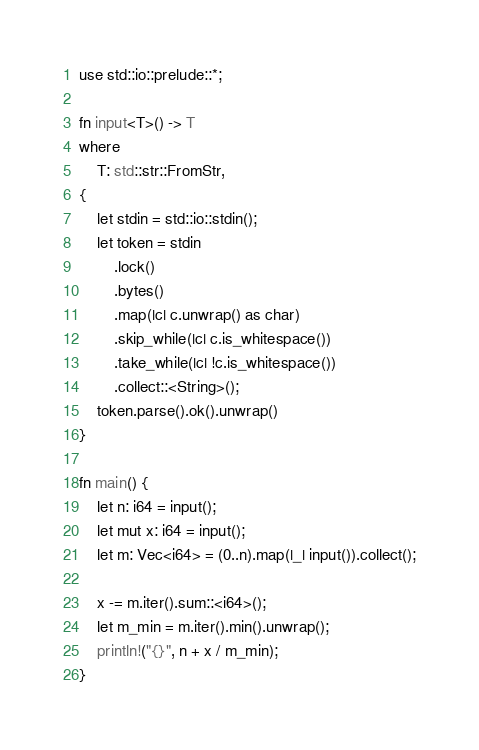Convert code to text. <code><loc_0><loc_0><loc_500><loc_500><_Rust_>use std::io::prelude::*;

fn input<T>() -> T
where
    T: std::str::FromStr,
{
    let stdin = std::io::stdin();
    let token = stdin
        .lock()
        .bytes()
        .map(|c| c.unwrap() as char)
        .skip_while(|c| c.is_whitespace())
        .take_while(|c| !c.is_whitespace())
        .collect::<String>();
    token.parse().ok().unwrap()
}

fn main() {
    let n: i64 = input();
    let mut x: i64 = input();
    let m: Vec<i64> = (0..n).map(|_| input()).collect();

    x -= m.iter().sum::<i64>();
    let m_min = m.iter().min().unwrap();
    println!("{}", n + x / m_min);
}
</code> 